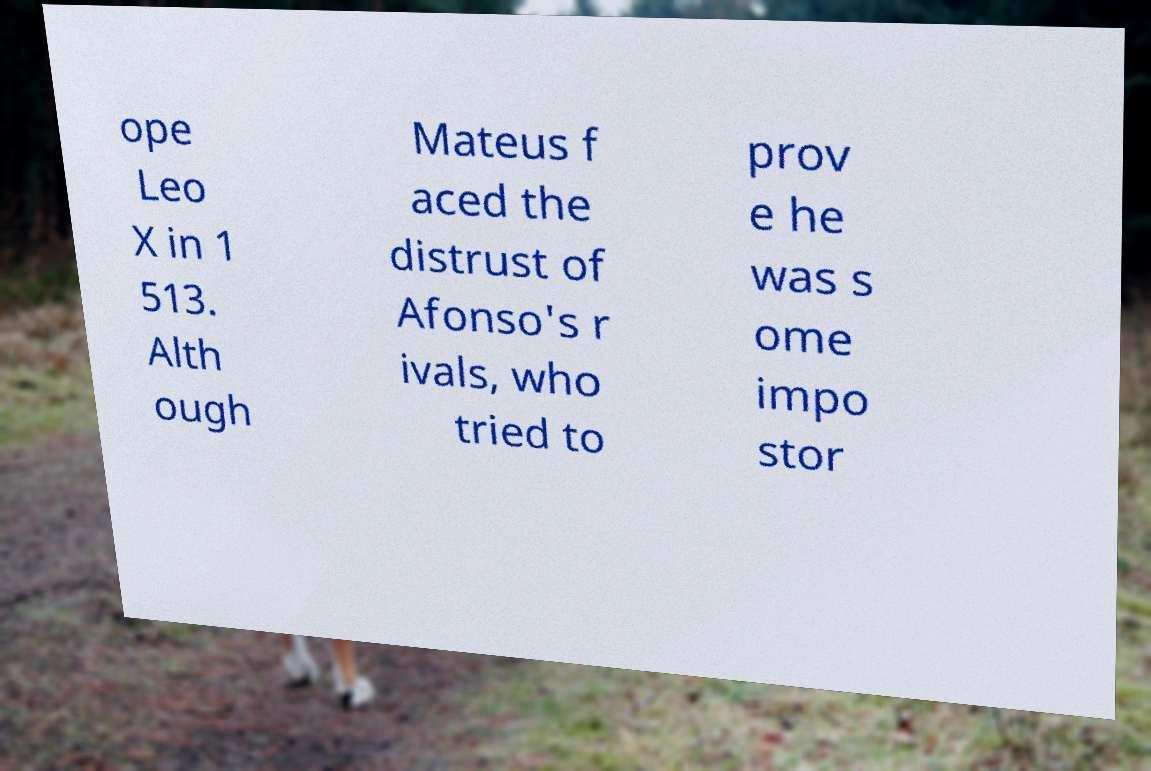There's text embedded in this image that I need extracted. Can you transcribe it verbatim? ope Leo X in 1 513. Alth ough Mateus f aced the distrust of Afonso's r ivals, who tried to prov e he was s ome impo stor 